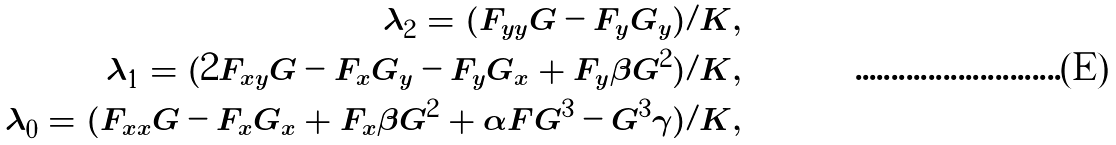<formula> <loc_0><loc_0><loc_500><loc_500>\lambda _ { 2 } = ( F _ { y y } G - F _ { y } G _ { y } ) / K , \\ \lambda _ { 1 } = ( 2 F _ { x y } G - F _ { x } G _ { y } - F _ { y } G _ { x } + F _ { y } \beta G ^ { 2 } ) / K , \\ \lambda _ { 0 } = ( F _ { x x } G - F _ { x } G _ { x } + F _ { x } \beta G ^ { 2 } + \alpha F G ^ { 3 } - G ^ { 3 } \gamma ) / K ,</formula> 